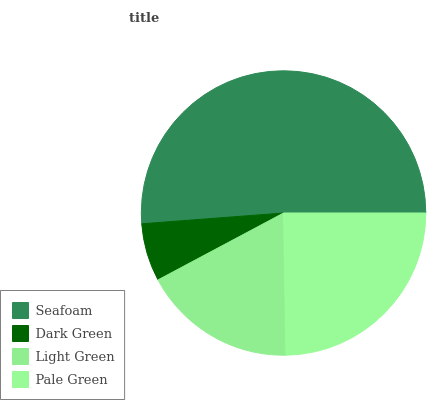Is Dark Green the minimum?
Answer yes or no. Yes. Is Seafoam the maximum?
Answer yes or no. Yes. Is Light Green the minimum?
Answer yes or no. No. Is Light Green the maximum?
Answer yes or no. No. Is Light Green greater than Dark Green?
Answer yes or no. Yes. Is Dark Green less than Light Green?
Answer yes or no. Yes. Is Dark Green greater than Light Green?
Answer yes or no. No. Is Light Green less than Dark Green?
Answer yes or no. No. Is Pale Green the high median?
Answer yes or no. Yes. Is Light Green the low median?
Answer yes or no. Yes. Is Seafoam the high median?
Answer yes or no. No. Is Pale Green the low median?
Answer yes or no. No. 